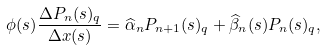<formula> <loc_0><loc_0><loc_500><loc_500>\phi ( s ) \frac { \Delta P _ { n } ( s ) _ { q } } { \Delta x ( s ) } = \widehat { \alpha } _ { n } P _ { n + 1 } ( s ) _ { q } + \widehat { \beta } _ { n } ( s ) P _ { n } ( s ) _ { q } ,</formula> 